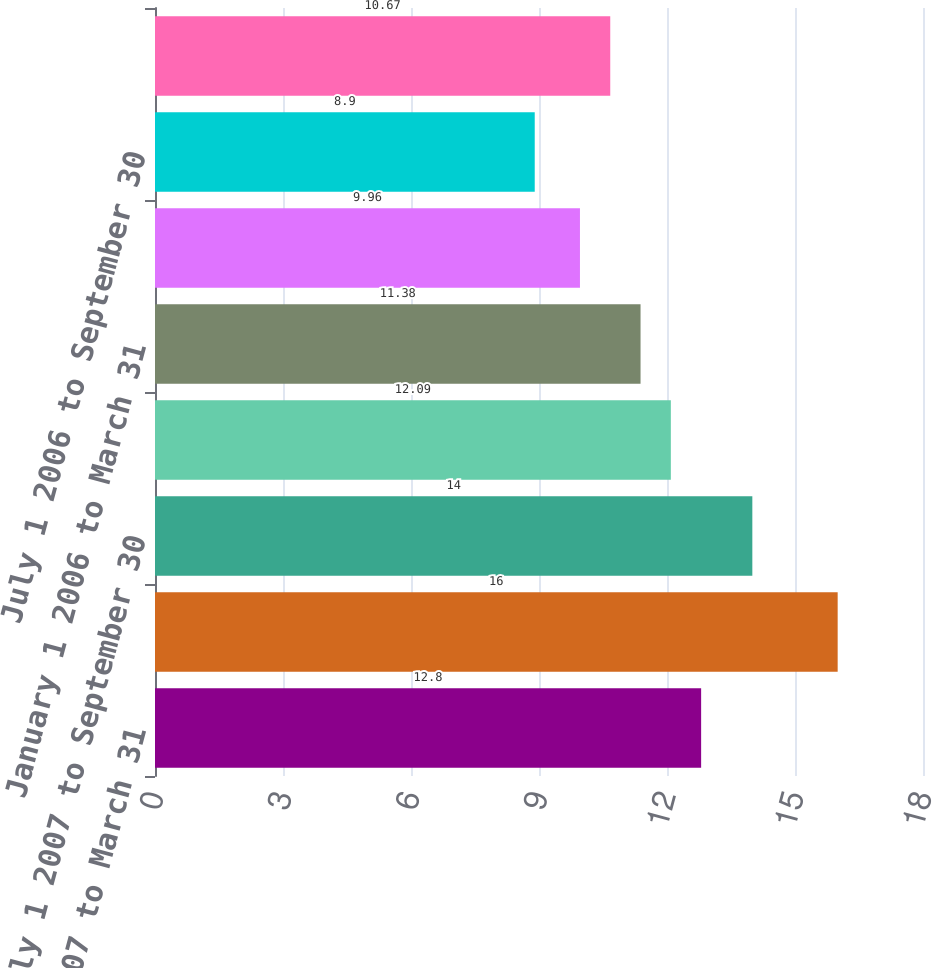Convert chart. <chart><loc_0><loc_0><loc_500><loc_500><bar_chart><fcel>January 1 2007 to March 31<fcel>April 1 2007 to June 30 2007<fcel>July 1 2007 to September 30<fcel>October 1 2007 to December 31<fcel>January 1 2006 to March 31<fcel>April 1 2006 to June 30 2006<fcel>July 1 2006 to September 30<fcel>October 1 2006 to December 31<nl><fcel>12.8<fcel>16<fcel>14<fcel>12.09<fcel>11.38<fcel>9.96<fcel>8.9<fcel>10.67<nl></chart> 